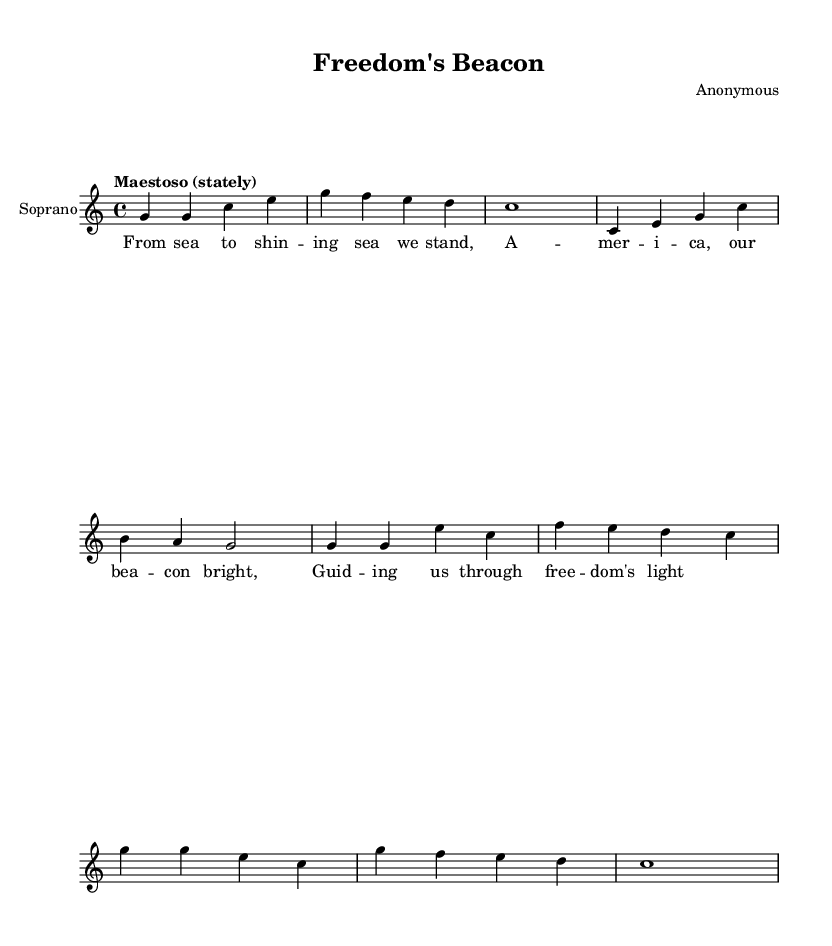What is the key signature of this music? The key signature is indicated at the beginning of the sheet music, showing no sharps or flats. This corresponds to C major.
Answer: C major What is the time signature of this piece? The time signature is located at the beginning, showing that the piece is counted in 4 beats per measure, which is 4/4.
Answer: 4/4 What is the tempo marking for this composition? The tempo marking is written as "Maestoso," indicating a stately or majestic pace for the piece.
Answer: Maestoso How many measures are in the introduction? By counting the individual units of music notation in the introduction segment, we can see there are four measures.
Answer: 4 What is the first line of the lyrics for the verse? The lyrics for the verse begin with "From sea to shin -- ing sea we stand," as clearly outlined under the musical notes.
Answer: From sea to shining sea we stand What is the length of the chorus as written in measures? The chorus, as indicated by its musical structure and the notated notes, consists of four distinct measures.
Answer: 4 Which vocalist part is featured in this score? The score explicitly designates that the part is for Soprano, as indicated in the header and the staff labeled as "Soprano."
Answer: Soprano 